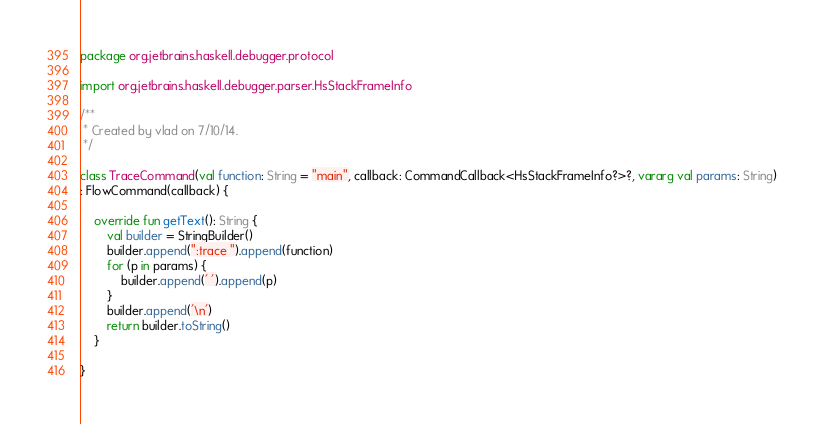<code> <loc_0><loc_0><loc_500><loc_500><_Kotlin_>package org.jetbrains.haskell.debugger.protocol

import org.jetbrains.haskell.debugger.parser.HsStackFrameInfo

/**
 * Created by vlad on 7/10/14.
 */

class TraceCommand(val function: String = "main", callback: CommandCallback<HsStackFrameInfo?>?, vararg val params: String)
: FlowCommand(callback) {

    override fun getText(): String {
        val builder = StringBuilder()
        builder.append(":trace ").append(function)
        for (p in params) {
            builder.append(' ').append(p)
        }
        builder.append('\n')
        return builder.toString()
    }

}</code> 